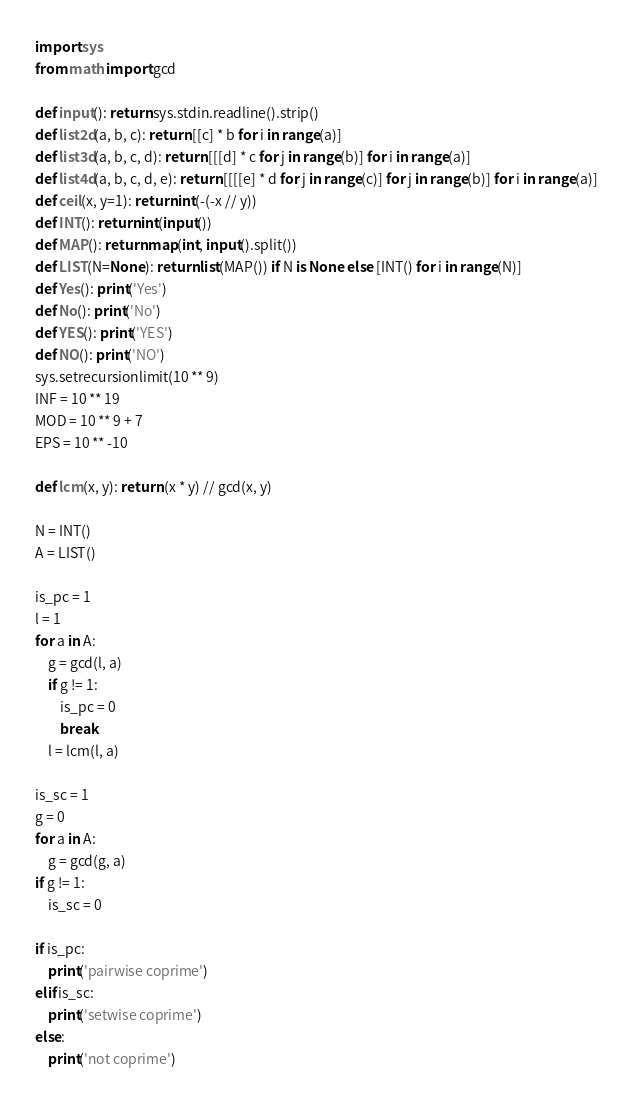Convert code to text. <code><loc_0><loc_0><loc_500><loc_500><_Python_>import sys
from math import gcd

def input(): return sys.stdin.readline().strip()
def list2d(a, b, c): return [[c] * b for i in range(a)]
def list3d(a, b, c, d): return [[[d] * c for j in range(b)] for i in range(a)]
def list4d(a, b, c, d, e): return [[[[e] * d for j in range(c)] for j in range(b)] for i in range(a)]
def ceil(x, y=1): return int(-(-x // y))
def INT(): return int(input())
def MAP(): return map(int, input().split())
def LIST(N=None): return list(MAP()) if N is None else [INT() for i in range(N)]
def Yes(): print('Yes')
def No(): print('No')
def YES(): print('YES')
def NO(): print('NO')
sys.setrecursionlimit(10 ** 9)
INF = 10 ** 19
MOD = 10 ** 9 + 7
EPS = 10 ** -10

def lcm(x, y): return (x * y) // gcd(x, y)

N = INT()
A = LIST()

is_pc = 1
l = 1
for a in A:
    g = gcd(l, a)
    if g != 1:
        is_pc = 0
        break
    l = lcm(l, a)

is_sc = 1
g = 0
for a in A:
    g = gcd(g, a)
if g != 1:
    is_sc = 0

if is_pc:
    print('pairwise coprime')
elif is_sc:
    print('setwise coprime')
else:
    print('not coprime')
</code> 